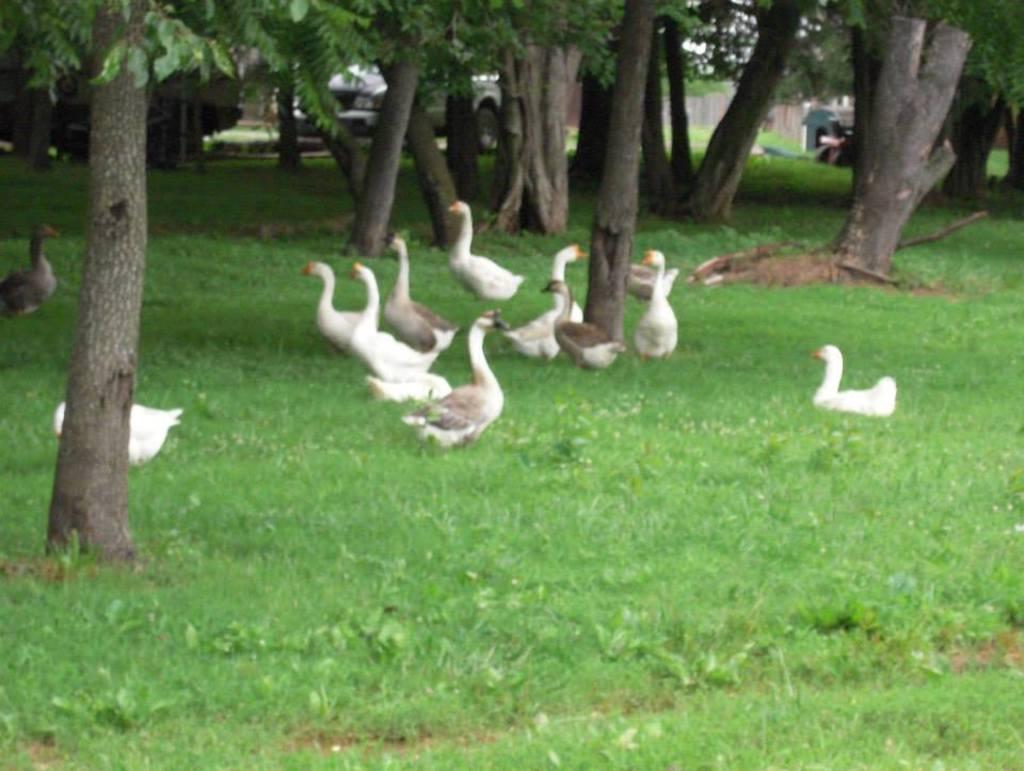In one or two sentences, can you explain what this image depicts? In this image we can see ducks on the grassy land. Behind trees and cars are present. 